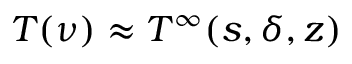<formula> <loc_0><loc_0><loc_500><loc_500>T ( \nu ) \approx T ^ { \infty } ( s , \delta , z )</formula> 